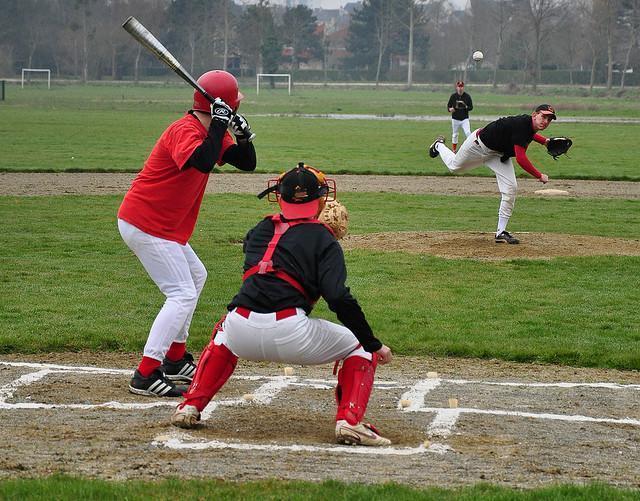How many people are standing in the grass?
Give a very brief answer. 1. How many people are in the photo?
Give a very brief answer. 3. How many bowls are there?
Give a very brief answer. 0. 